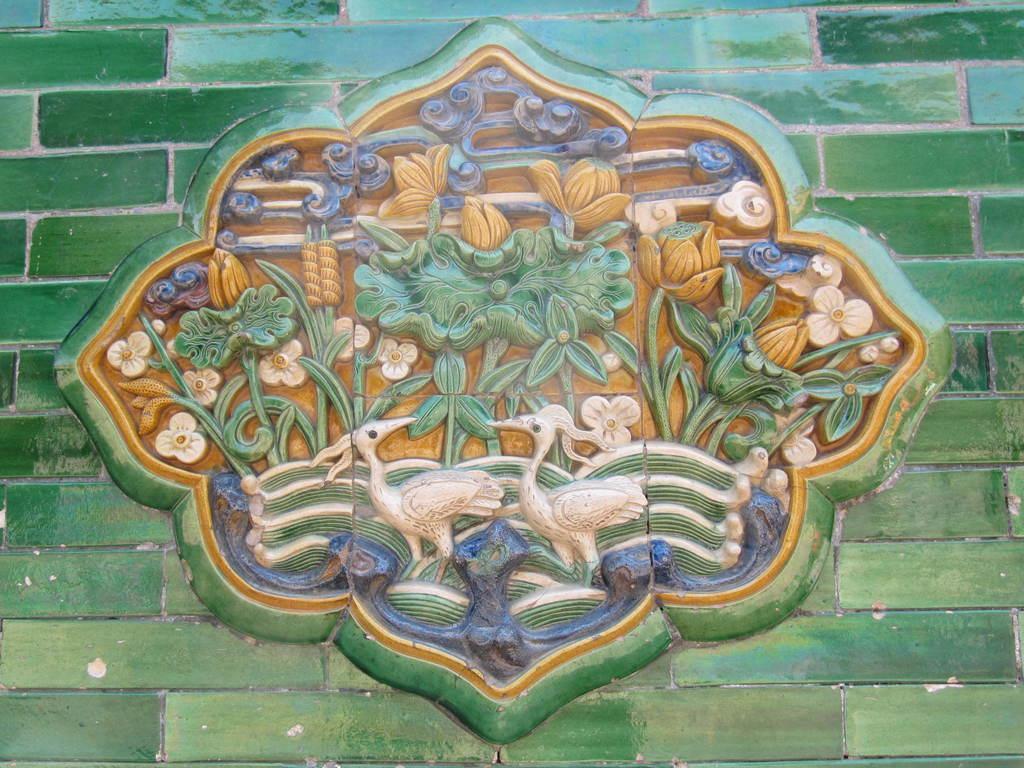In one or two sentences, can you explain what this image depicts? In this image, we can see carvings on the wall. 